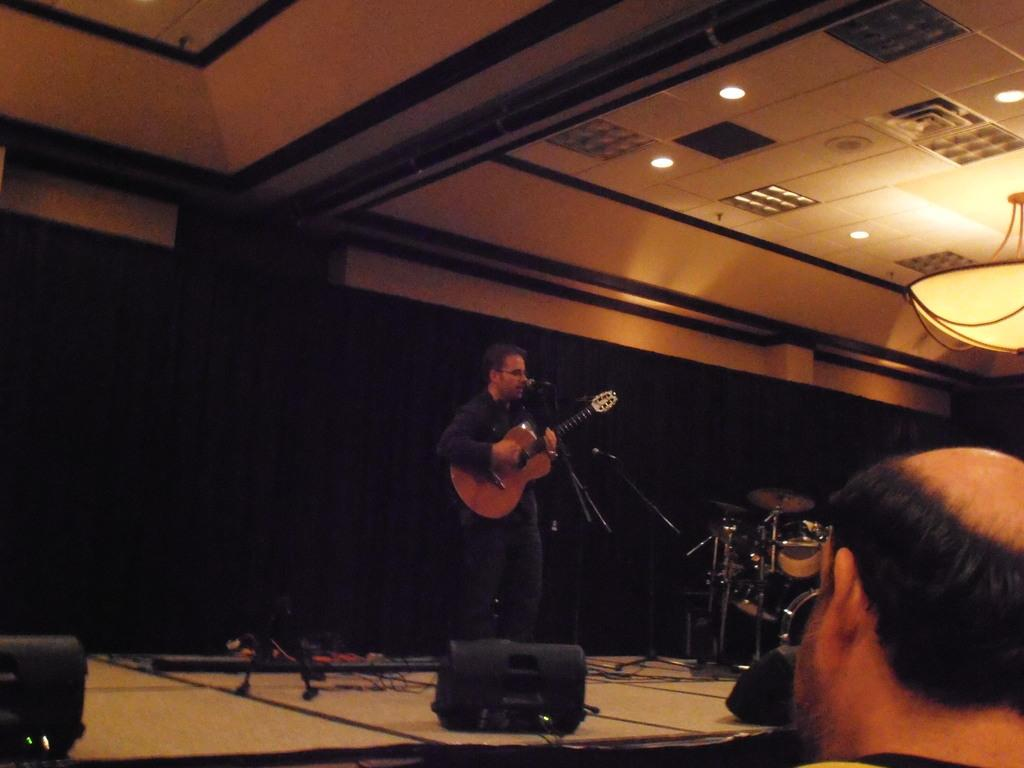What is the man in the image doing? The man is playing a guitar and singing a song in the image. What is the man using to amplify his voice? There is a microphone in front of the man. What other musical instrument is present in the image? There are drums beside the man. Is there anyone else in the image? Yes, there is another man present in the image. What type of wound can be seen on the man's hand while he is playing the guitar? There is no wound visible on the man's hand in the image. Can you describe the sidewalk where the musicians are performing? There is no sidewalk present in the image; it appears to be an indoor setting. 